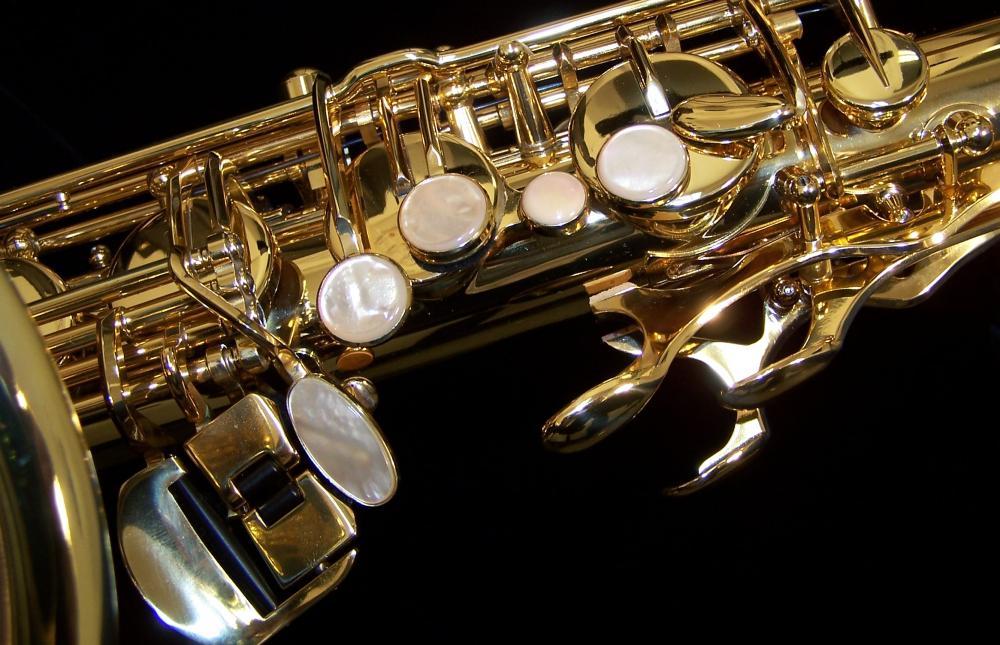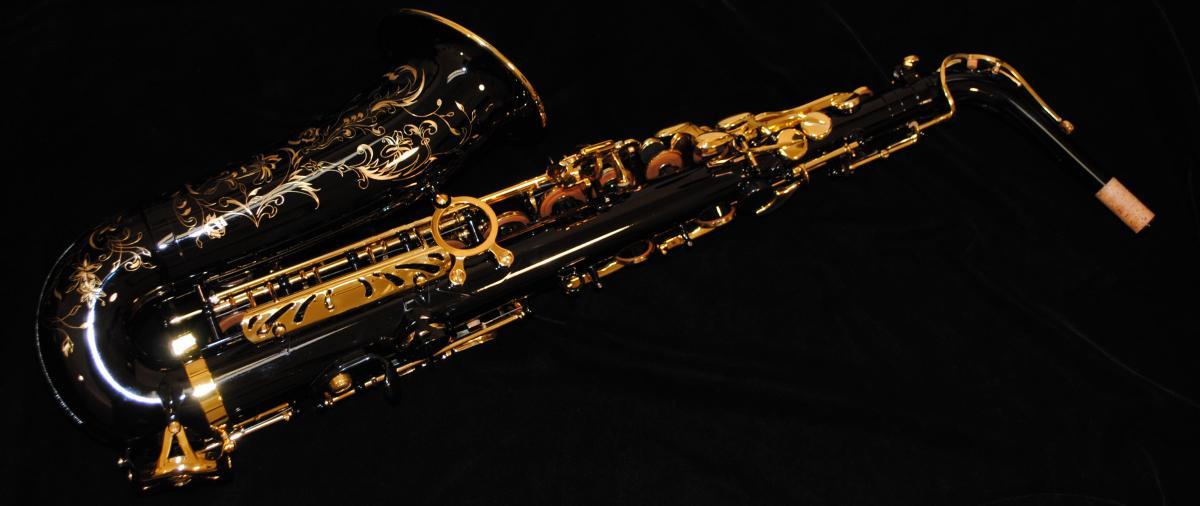The first image is the image on the left, the second image is the image on the right. Assess this claim about the two images: "The right image shows a saxophone displayed nearly horizontally, with its mouthpiece attached and facing upward.". Correct or not? Answer yes or no. No. 